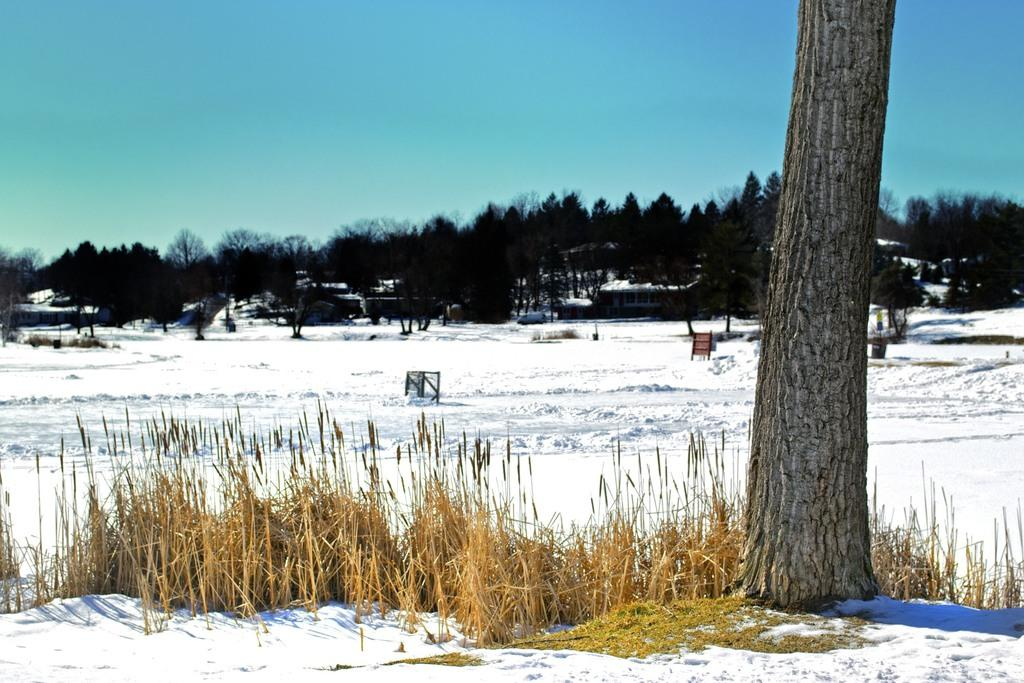What is the condition of the land in the image? The land is covered with snow in the image. What type of vegetation can be seen in the image? There are plants and a tree in the image. What can be seen in the background of the image? The background of the image includes trees, houses, boards, and a vehicle. What is the color of the sky in the image? The sky is blue in the background of the image. What type of machine is sparking in the image? There is no machine or sparking present in the image; it features a snow-covered landscape with various background elements. 